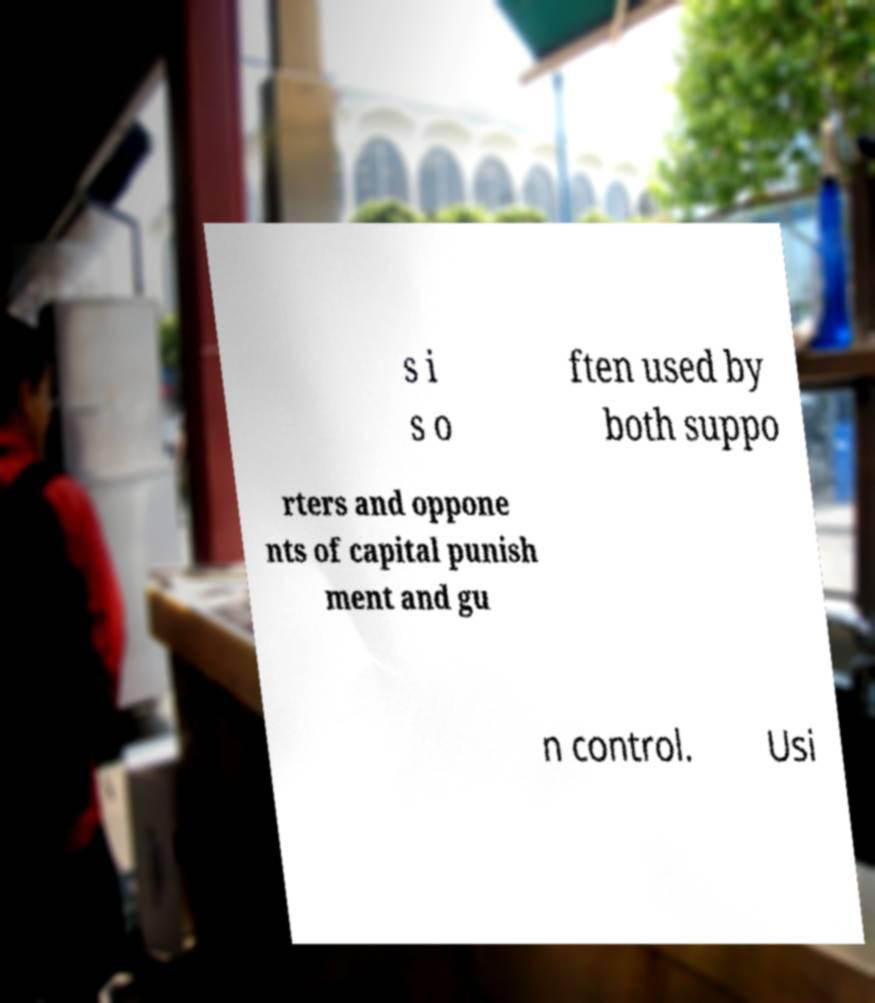There's text embedded in this image that I need extracted. Can you transcribe it verbatim? s i s o ften used by both suppo rters and oppone nts of capital punish ment and gu n control. Usi 